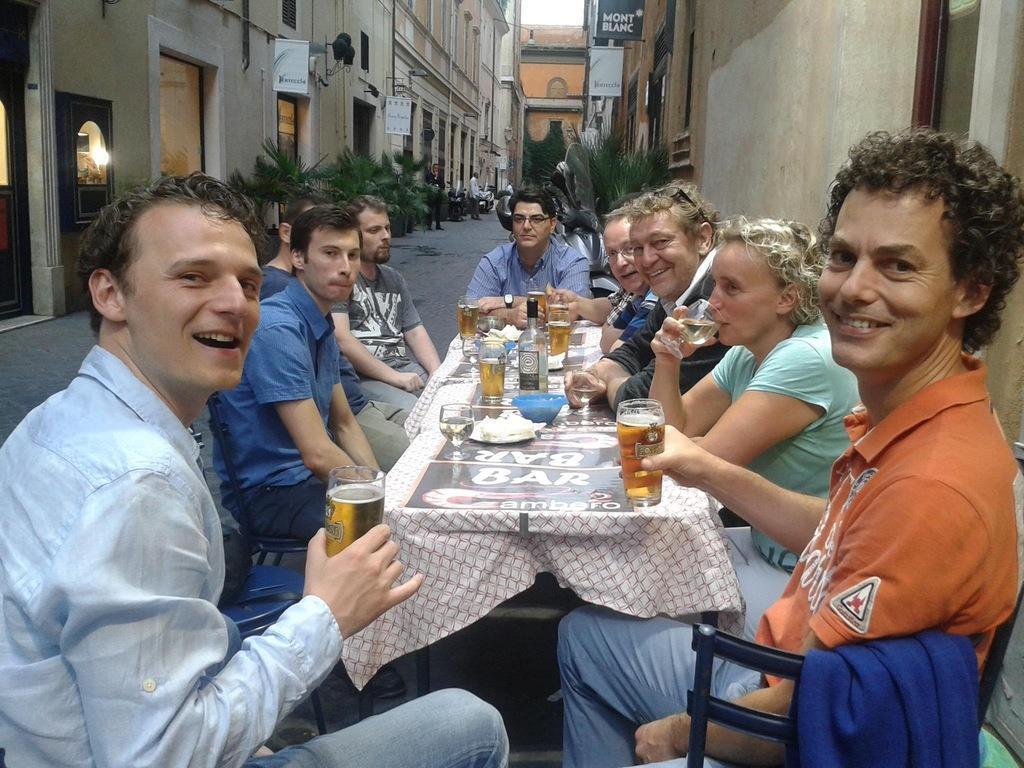How would you summarize this image in a sentence or two? There are group of people sitting on the chairs. This is a table covered with a cloth. There is a plate,bowl,wine glass,beer tumbler and a bottle placed on the table. At background I can see buildings,plants and few people standing. These are the small banners attached to the pole. 